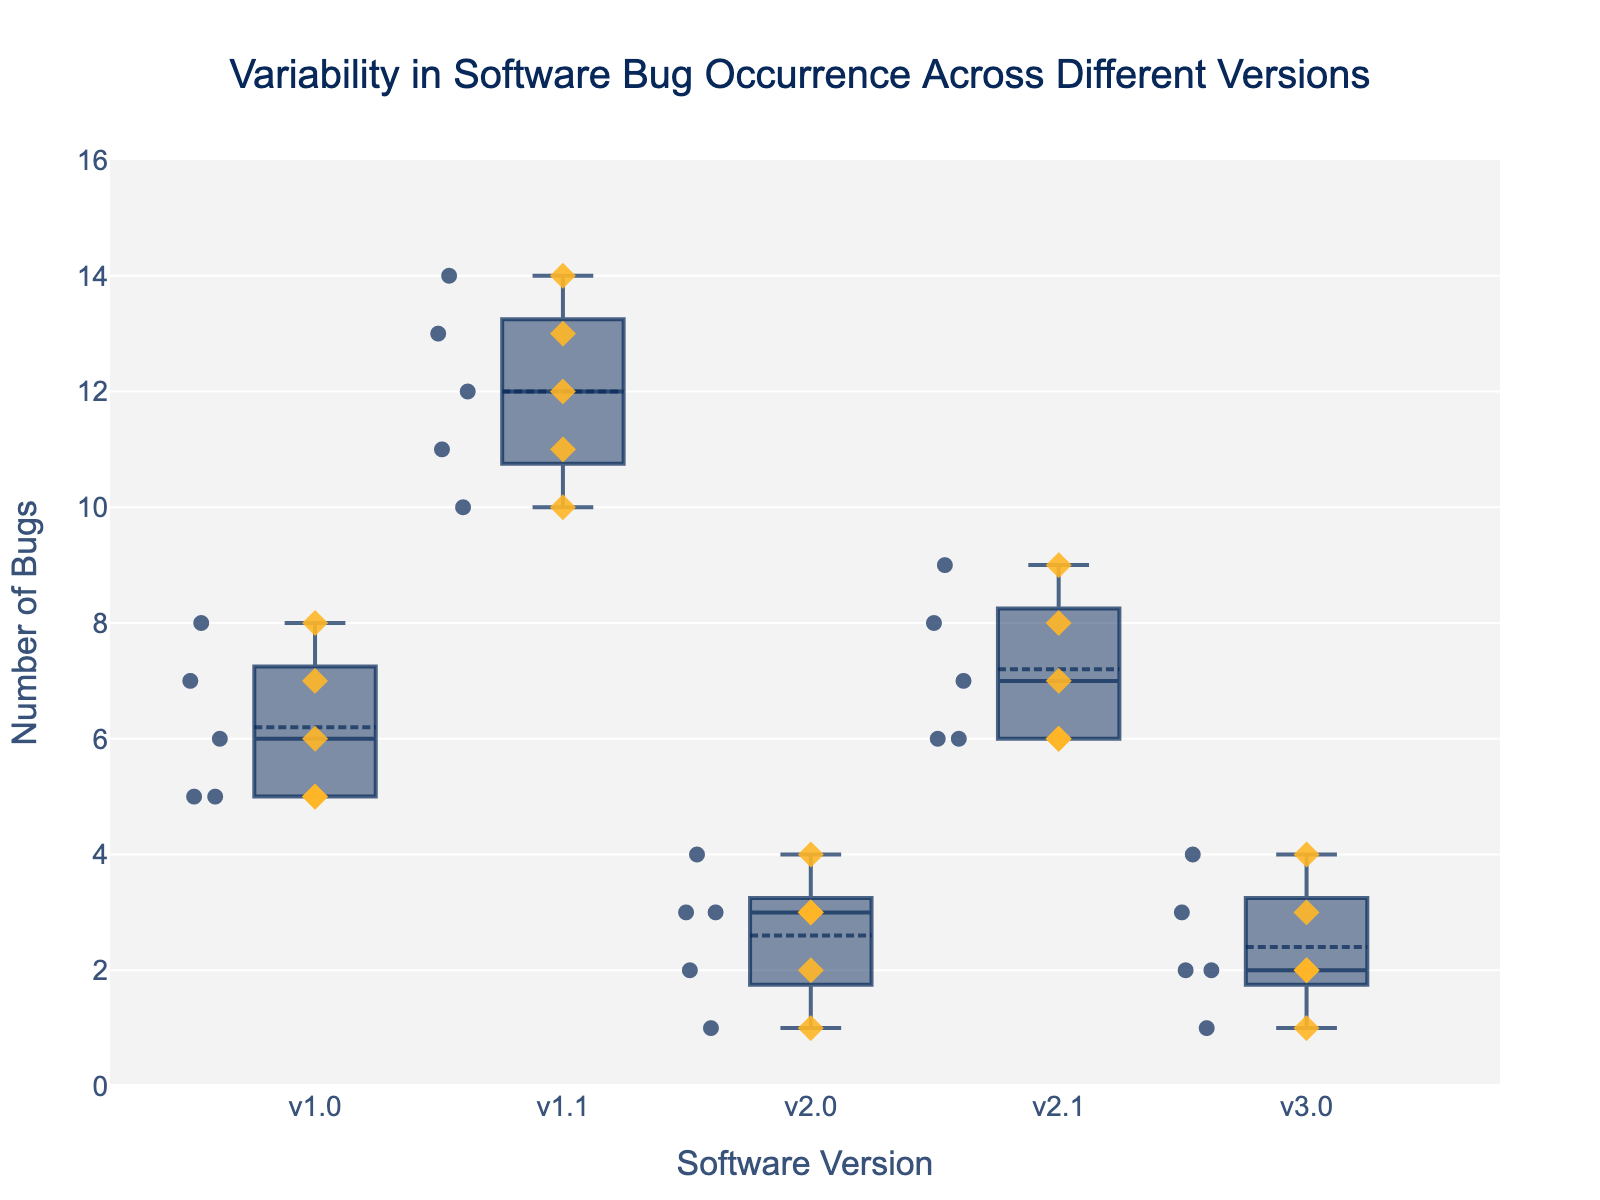what is the title of the plot? The title is commonly placed at the top middle of the plot and easily identifiable. It provides a quick summary of what the plot represents.
Answer: Variability in Software Bug Occurrence Across Different Versions What is the median number of bugs in version v1.1? In a box plot, the median is represented by the line inside the box. For version v1.1, locate the median line to find the value.
Answer: 12 Which software version has the highest average number of bugs? The average value can be inferred from the box plot’s mean markers, noted as a small circle or symbol in the box. Compare these markers across all versions.
Answer: v1.1 Which software version shows the least variation in the number of bugs? Variation in a box plot is indicated by the length of the interquartile range (IQR) box. A smaller IQR means less variation. Compare the lengths of the IQR boxes for all versions.
Answer: v3.0 How does the range of bug occurrences in version v2.0 compare to that in version v1.0? The range in a box plot is shown by the distance between the minimum and maximum whiskers or points. Measure the distance in both versions to compare the ranges.
Answer: v2.0 < v1.0 What is the maximum number of bugs recorded in version v2.1? The maximum value in a box plot is identified by the top whisker or highest point above the box for that version.
Answer: 9 Which version has the lowest minimum number of bugs? The minimum value in a box plot is indicated by the bottom whisker or lowest point below the box for that version. Compare these across versions to find the lowest.
Answer: v2.0 Is there an outlier in the bug data for any version? Outliers in box plots are represented as individual points outside the whiskers. Examine each version for any points noticeably detached from the whiskers.
Answer: No Which software version has the most uniform number of bugs? Uniformity can be assessed by looking at the scatter points; the less spread out they are, the more uniform. Compare scatter points across versions.
Answer: v3.0 When comparing version v1.0 and v2.1, which one has a higher third quartile value? The third quartile (Q3) is the top boundary of the box in a box plot. Compare the Q3 values of versions v1.0 and v2.1.
Answer: v2.1 